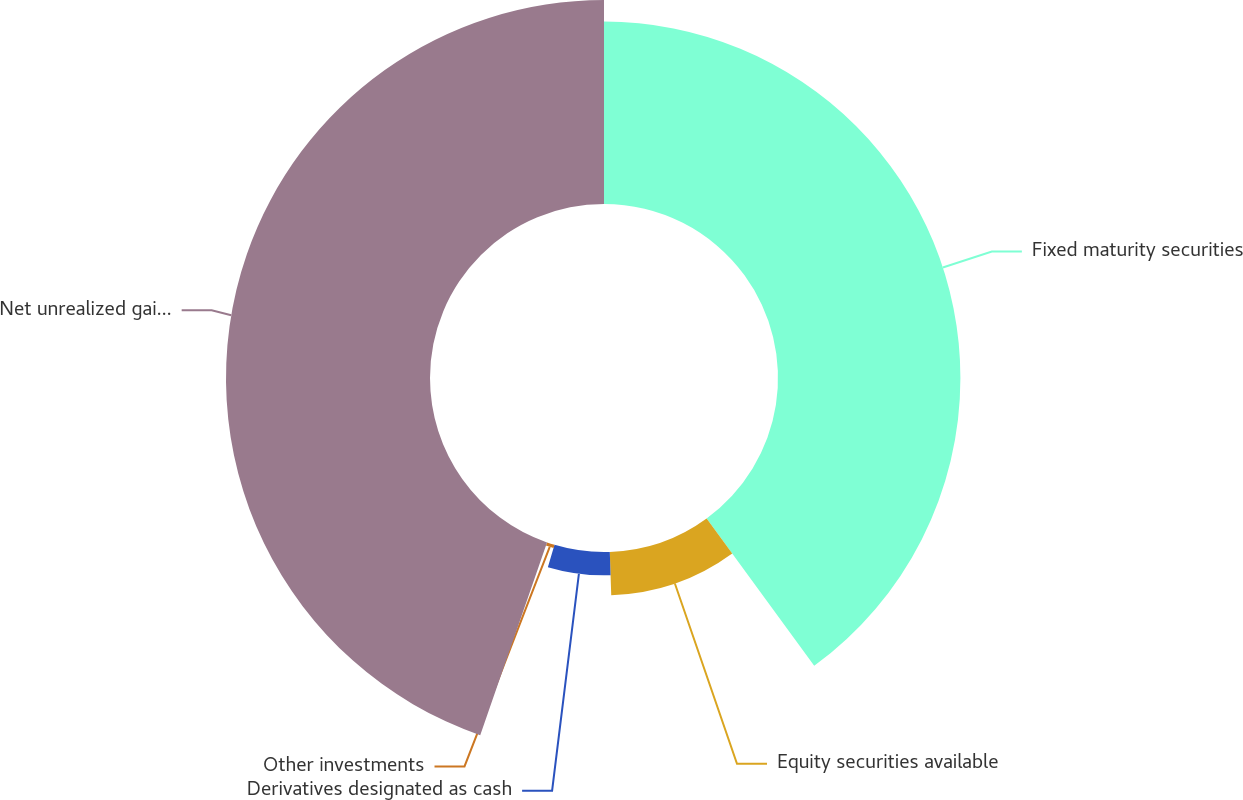Convert chart to OTSL. <chart><loc_0><loc_0><loc_500><loc_500><pie_chart><fcel>Fixed maturity securities<fcel>Equity securities available<fcel>Derivatives designated as cash<fcel>Other investments<fcel>Net unrealized gains (losses)<nl><fcel>39.96%<fcel>9.51%<fcel>5.12%<fcel>0.72%<fcel>44.69%<nl></chart> 